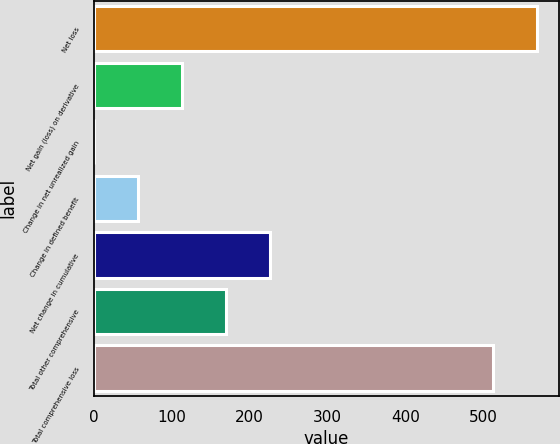<chart> <loc_0><loc_0><loc_500><loc_500><bar_chart><fcel>Net loss<fcel>Net gain (loss) on derivative<fcel>Change in net unrealized gain<fcel>Change in defined benefit<fcel>Net change in cumulative<fcel>Total other comprehensive<fcel>Total comprehensive loss<nl><fcel>568.87<fcel>113.54<fcel>0.2<fcel>56.87<fcel>226.88<fcel>170.21<fcel>512.2<nl></chart> 